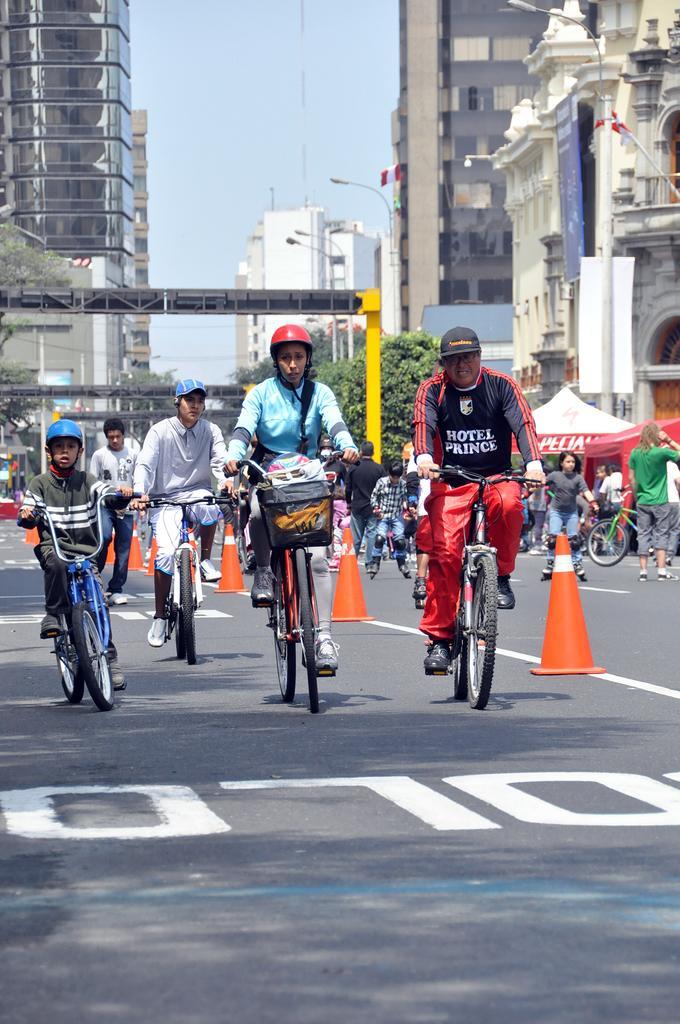In one or two sentences, can you explain what this image depicts? There are a four people riding a bicycle on the road. In the background we can see buildings and a few people on the right side. 